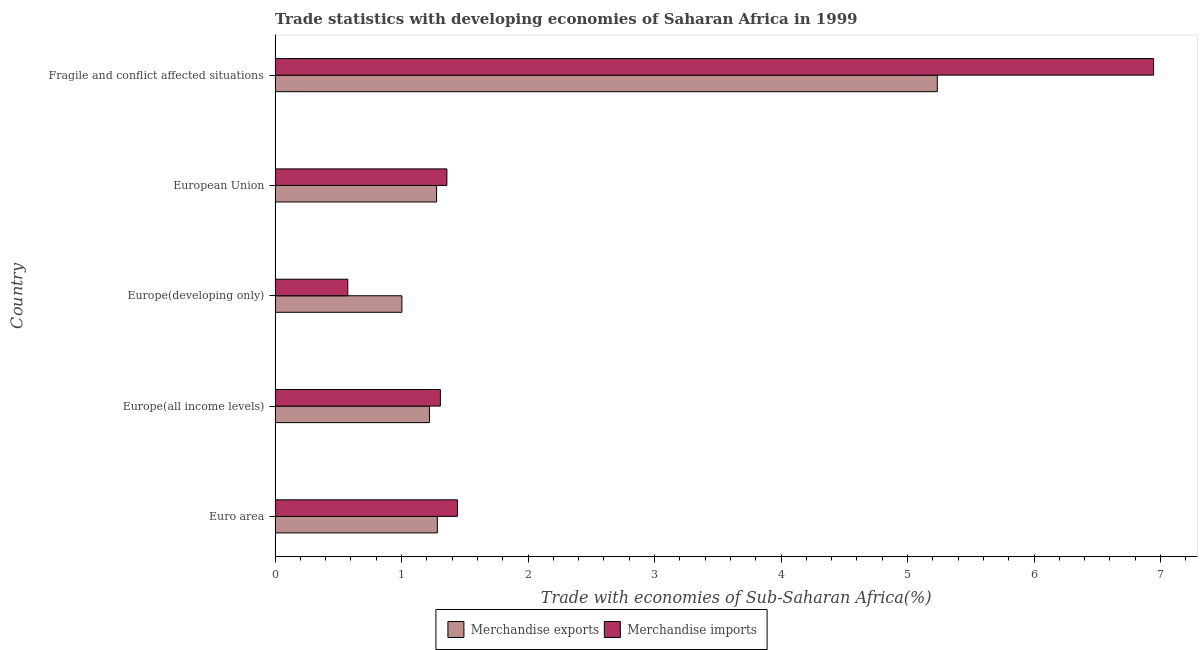Are the number of bars per tick equal to the number of legend labels?
Your answer should be very brief. Yes. How many bars are there on the 5th tick from the top?
Make the answer very short. 2. What is the label of the 3rd group of bars from the top?
Provide a short and direct response. Europe(developing only). In how many cases, is the number of bars for a given country not equal to the number of legend labels?
Keep it short and to the point. 0. What is the merchandise exports in Europe(all income levels)?
Your answer should be very brief. 1.22. Across all countries, what is the maximum merchandise imports?
Offer a terse response. 6.94. Across all countries, what is the minimum merchandise exports?
Offer a very short reply. 1. In which country was the merchandise imports maximum?
Give a very brief answer. Fragile and conflict affected situations. In which country was the merchandise exports minimum?
Your answer should be very brief. Europe(developing only). What is the total merchandise imports in the graph?
Offer a very short reply. 11.63. What is the difference between the merchandise imports in Europe(developing only) and that in European Union?
Ensure brevity in your answer.  -0.78. What is the difference between the merchandise imports in Europe(all income levels) and the merchandise exports in European Union?
Provide a succinct answer. 0.03. What is the average merchandise imports per country?
Provide a short and direct response. 2.33. What is the difference between the merchandise exports and merchandise imports in Europe(all income levels)?
Your response must be concise. -0.09. In how many countries, is the merchandise imports greater than 7 %?
Your answer should be compact. 0. What is the ratio of the merchandise imports in Euro area to that in Europe(all income levels)?
Your answer should be compact. 1.1. Is the merchandise exports in European Union less than that in Fragile and conflict affected situations?
Provide a succinct answer. Yes. What is the difference between the highest and the second highest merchandise exports?
Offer a very short reply. 3.95. What is the difference between the highest and the lowest merchandise imports?
Ensure brevity in your answer.  6.37. In how many countries, is the merchandise imports greater than the average merchandise imports taken over all countries?
Ensure brevity in your answer.  1. What does the 2nd bar from the top in Fragile and conflict affected situations represents?
Your response must be concise. Merchandise exports. What does the 1st bar from the bottom in European Union represents?
Offer a very short reply. Merchandise exports. How many countries are there in the graph?
Your answer should be compact. 5. What is the difference between two consecutive major ticks on the X-axis?
Ensure brevity in your answer.  1. Are the values on the major ticks of X-axis written in scientific E-notation?
Your answer should be very brief. No. Does the graph contain any zero values?
Keep it short and to the point. No. Does the graph contain grids?
Provide a succinct answer. No. How many legend labels are there?
Keep it short and to the point. 2. How are the legend labels stacked?
Offer a terse response. Horizontal. What is the title of the graph?
Give a very brief answer. Trade statistics with developing economies of Saharan Africa in 1999. Does "Domestic liabilities" appear as one of the legend labels in the graph?
Provide a short and direct response. No. What is the label or title of the X-axis?
Your response must be concise. Trade with economies of Sub-Saharan Africa(%). What is the Trade with economies of Sub-Saharan Africa(%) in Merchandise exports in Euro area?
Your response must be concise. 1.28. What is the Trade with economies of Sub-Saharan Africa(%) of Merchandise imports in Euro area?
Give a very brief answer. 1.44. What is the Trade with economies of Sub-Saharan Africa(%) of Merchandise exports in Europe(all income levels)?
Your answer should be very brief. 1.22. What is the Trade with economies of Sub-Saharan Africa(%) in Merchandise imports in Europe(all income levels)?
Your response must be concise. 1.31. What is the Trade with economies of Sub-Saharan Africa(%) of Merchandise exports in Europe(developing only)?
Offer a very short reply. 1. What is the Trade with economies of Sub-Saharan Africa(%) in Merchandise imports in Europe(developing only)?
Offer a very short reply. 0.57. What is the Trade with economies of Sub-Saharan Africa(%) in Merchandise exports in European Union?
Your response must be concise. 1.28. What is the Trade with economies of Sub-Saharan Africa(%) of Merchandise imports in European Union?
Your answer should be very brief. 1.36. What is the Trade with economies of Sub-Saharan Africa(%) of Merchandise exports in Fragile and conflict affected situations?
Provide a succinct answer. 5.24. What is the Trade with economies of Sub-Saharan Africa(%) in Merchandise imports in Fragile and conflict affected situations?
Your response must be concise. 6.94. Across all countries, what is the maximum Trade with economies of Sub-Saharan Africa(%) in Merchandise exports?
Keep it short and to the point. 5.24. Across all countries, what is the maximum Trade with economies of Sub-Saharan Africa(%) of Merchandise imports?
Make the answer very short. 6.94. Across all countries, what is the minimum Trade with economies of Sub-Saharan Africa(%) of Merchandise exports?
Your response must be concise. 1. Across all countries, what is the minimum Trade with economies of Sub-Saharan Africa(%) of Merchandise imports?
Give a very brief answer. 0.57. What is the total Trade with economies of Sub-Saharan Africa(%) in Merchandise exports in the graph?
Give a very brief answer. 10.02. What is the total Trade with economies of Sub-Saharan Africa(%) in Merchandise imports in the graph?
Offer a terse response. 11.63. What is the difference between the Trade with economies of Sub-Saharan Africa(%) in Merchandise exports in Euro area and that in Europe(all income levels)?
Ensure brevity in your answer.  0.06. What is the difference between the Trade with economies of Sub-Saharan Africa(%) in Merchandise imports in Euro area and that in Europe(all income levels)?
Make the answer very short. 0.14. What is the difference between the Trade with economies of Sub-Saharan Africa(%) of Merchandise exports in Euro area and that in Europe(developing only)?
Your response must be concise. 0.28. What is the difference between the Trade with economies of Sub-Saharan Africa(%) of Merchandise imports in Euro area and that in Europe(developing only)?
Your answer should be very brief. 0.87. What is the difference between the Trade with economies of Sub-Saharan Africa(%) in Merchandise exports in Euro area and that in European Union?
Offer a very short reply. 0.01. What is the difference between the Trade with economies of Sub-Saharan Africa(%) in Merchandise imports in Euro area and that in European Union?
Offer a terse response. 0.08. What is the difference between the Trade with economies of Sub-Saharan Africa(%) of Merchandise exports in Euro area and that in Fragile and conflict affected situations?
Provide a short and direct response. -3.95. What is the difference between the Trade with economies of Sub-Saharan Africa(%) of Merchandise imports in Euro area and that in Fragile and conflict affected situations?
Provide a succinct answer. -5.5. What is the difference between the Trade with economies of Sub-Saharan Africa(%) in Merchandise exports in Europe(all income levels) and that in Europe(developing only)?
Make the answer very short. 0.22. What is the difference between the Trade with economies of Sub-Saharan Africa(%) of Merchandise imports in Europe(all income levels) and that in Europe(developing only)?
Ensure brevity in your answer.  0.73. What is the difference between the Trade with economies of Sub-Saharan Africa(%) in Merchandise exports in Europe(all income levels) and that in European Union?
Provide a succinct answer. -0.06. What is the difference between the Trade with economies of Sub-Saharan Africa(%) of Merchandise imports in Europe(all income levels) and that in European Union?
Make the answer very short. -0.05. What is the difference between the Trade with economies of Sub-Saharan Africa(%) of Merchandise exports in Europe(all income levels) and that in Fragile and conflict affected situations?
Ensure brevity in your answer.  -4.01. What is the difference between the Trade with economies of Sub-Saharan Africa(%) of Merchandise imports in Europe(all income levels) and that in Fragile and conflict affected situations?
Make the answer very short. -5.64. What is the difference between the Trade with economies of Sub-Saharan Africa(%) of Merchandise exports in Europe(developing only) and that in European Union?
Provide a short and direct response. -0.27. What is the difference between the Trade with economies of Sub-Saharan Africa(%) in Merchandise imports in Europe(developing only) and that in European Union?
Offer a very short reply. -0.78. What is the difference between the Trade with economies of Sub-Saharan Africa(%) in Merchandise exports in Europe(developing only) and that in Fragile and conflict affected situations?
Your answer should be compact. -4.23. What is the difference between the Trade with economies of Sub-Saharan Africa(%) of Merchandise imports in Europe(developing only) and that in Fragile and conflict affected situations?
Your answer should be compact. -6.37. What is the difference between the Trade with economies of Sub-Saharan Africa(%) of Merchandise exports in European Union and that in Fragile and conflict affected situations?
Your answer should be compact. -3.96. What is the difference between the Trade with economies of Sub-Saharan Africa(%) in Merchandise imports in European Union and that in Fragile and conflict affected situations?
Your response must be concise. -5.59. What is the difference between the Trade with economies of Sub-Saharan Africa(%) in Merchandise exports in Euro area and the Trade with economies of Sub-Saharan Africa(%) in Merchandise imports in Europe(all income levels)?
Your answer should be compact. -0.02. What is the difference between the Trade with economies of Sub-Saharan Africa(%) of Merchandise exports in Euro area and the Trade with economies of Sub-Saharan Africa(%) of Merchandise imports in Europe(developing only)?
Offer a terse response. 0.71. What is the difference between the Trade with economies of Sub-Saharan Africa(%) in Merchandise exports in Euro area and the Trade with economies of Sub-Saharan Africa(%) in Merchandise imports in European Union?
Ensure brevity in your answer.  -0.08. What is the difference between the Trade with economies of Sub-Saharan Africa(%) of Merchandise exports in Euro area and the Trade with economies of Sub-Saharan Africa(%) of Merchandise imports in Fragile and conflict affected situations?
Keep it short and to the point. -5.66. What is the difference between the Trade with economies of Sub-Saharan Africa(%) of Merchandise exports in Europe(all income levels) and the Trade with economies of Sub-Saharan Africa(%) of Merchandise imports in Europe(developing only)?
Keep it short and to the point. 0.65. What is the difference between the Trade with economies of Sub-Saharan Africa(%) in Merchandise exports in Europe(all income levels) and the Trade with economies of Sub-Saharan Africa(%) in Merchandise imports in European Union?
Provide a short and direct response. -0.14. What is the difference between the Trade with economies of Sub-Saharan Africa(%) in Merchandise exports in Europe(all income levels) and the Trade with economies of Sub-Saharan Africa(%) in Merchandise imports in Fragile and conflict affected situations?
Offer a terse response. -5.72. What is the difference between the Trade with economies of Sub-Saharan Africa(%) in Merchandise exports in Europe(developing only) and the Trade with economies of Sub-Saharan Africa(%) in Merchandise imports in European Union?
Provide a short and direct response. -0.36. What is the difference between the Trade with economies of Sub-Saharan Africa(%) in Merchandise exports in Europe(developing only) and the Trade with economies of Sub-Saharan Africa(%) in Merchandise imports in Fragile and conflict affected situations?
Give a very brief answer. -5.94. What is the difference between the Trade with economies of Sub-Saharan Africa(%) of Merchandise exports in European Union and the Trade with economies of Sub-Saharan Africa(%) of Merchandise imports in Fragile and conflict affected situations?
Offer a terse response. -5.67. What is the average Trade with economies of Sub-Saharan Africa(%) of Merchandise exports per country?
Keep it short and to the point. 2. What is the average Trade with economies of Sub-Saharan Africa(%) in Merchandise imports per country?
Your response must be concise. 2.33. What is the difference between the Trade with economies of Sub-Saharan Africa(%) of Merchandise exports and Trade with economies of Sub-Saharan Africa(%) of Merchandise imports in Euro area?
Make the answer very short. -0.16. What is the difference between the Trade with economies of Sub-Saharan Africa(%) of Merchandise exports and Trade with economies of Sub-Saharan Africa(%) of Merchandise imports in Europe(all income levels)?
Offer a very short reply. -0.09. What is the difference between the Trade with economies of Sub-Saharan Africa(%) of Merchandise exports and Trade with economies of Sub-Saharan Africa(%) of Merchandise imports in Europe(developing only)?
Offer a very short reply. 0.43. What is the difference between the Trade with economies of Sub-Saharan Africa(%) in Merchandise exports and Trade with economies of Sub-Saharan Africa(%) in Merchandise imports in European Union?
Offer a very short reply. -0.08. What is the difference between the Trade with economies of Sub-Saharan Africa(%) of Merchandise exports and Trade with economies of Sub-Saharan Africa(%) of Merchandise imports in Fragile and conflict affected situations?
Ensure brevity in your answer.  -1.71. What is the ratio of the Trade with economies of Sub-Saharan Africa(%) in Merchandise exports in Euro area to that in Europe(all income levels)?
Offer a very short reply. 1.05. What is the ratio of the Trade with economies of Sub-Saharan Africa(%) in Merchandise imports in Euro area to that in Europe(all income levels)?
Ensure brevity in your answer.  1.1. What is the ratio of the Trade with economies of Sub-Saharan Africa(%) in Merchandise exports in Euro area to that in Europe(developing only)?
Ensure brevity in your answer.  1.28. What is the ratio of the Trade with economies of Sub-Saharan Africa(%) in Merchandise imports in Euro area to that in Europe(developing only)?
Offer a very short reply. 2.51. What is the ratio of the Trade with economies of Sub-Saharan Africa(%) in Merchandise exports in Euro area to that in European Union?
Give a very brief answer. 1. What is the ratio of the Trade with economies of Sub-Saharan Africa(%) of Merchandise imports in Euro area to that in European Union?
Offer a very short reply. 1.06. What is the ratio of the Trade with economies of Sub-Saharan Africa(%) of Merchandise exports in Euro area to that in Fragile and conflict affected situations?
Your response must be concise. 0.24. What is the ratio of the Trade with economies of Sub-Saharan Africa(%) of Merchandise imports in Euro area to that in Fragile and conflict affected situations?
Give a very brief answer. 0.21. What is the ratio of the Trade with economies of Sub-Saharan Africa(%) in Merchandise exports in Europe(all income levels) to that in Europe(developing only)?
Give a very brief answer. 1.22. What is the ratio of the Trade with economies of Sub-Saharan Africa(%) of Merchandise imports in Europe(all income levels) to that in Europe(developing only)?
Your answer should be compact. 2.27. What is the ratio of the Trade with economies of Sub-Saharan Africa(%) of Merchandise exports in Europe(all income levels) to that in European Union?
Your response must be concise. 0.96. What is the ratio of the Trade with economies of Sub-Saharan Africa(%) of Merchandise imports in Europe(all income levels) to that in European Union?
Offer a terse response. 0.96. What is the ratio of the Trade with economies of Sub-Saharan Africa(%) in Merchandise exports in Europe(all income levels) to that in Fragile and conflict affected situations?
Give a very brief answer. 0.23. What is the ratio of the Trade with economies of Sub-Saharan Africa(%) of Merchandise imports in Europe(all income levels) to that in Fragile and conflict affected situations?
Provide a succinct answer. 0.19. What is the ratio of the Trade with economies of Sub-Saharan Africa(%) of Merchandise exports in Europe(developing only) to that in European Union?
Give a very brief answer. 0.79. What is the ratio of the Trade with economies of Sub-Saharan Africa(%) of Merchandise imports in Europe(developing only) to that in European Union?
Provide a short and direct response. 0.42. What is the ratio of the Trade with economies of Sub-Saharan Africa(%) in Merchandise exports in Europe(developing only) to that in Fragile and conflict affected situations?
Give a very brief answer. 0.19. What is the ratio of the Trade with economies of Sub-Saharan Africa(%) in Merchandise imports in Europe(developing only) to that in Fragile and conflict affected situations?
Offer a terse response. 0.08. What is the ratio of the Trade with economies of Sub-Saharan Africa(%) of Merchandise exports in European Union to that in Fragile and conflict affected situations?
Your answer should be compact. 0.24. What is the ratio of the Trade with economies of Sub-Saharan Africa(%) in Merchandise imports in European Union to that in Fragile and conflict affected situations?
Give a very brief answer. 0.2. What is the difference between the highest and the second highest Trade with economies of Sub-Saharan Africa(%) of Merchandise exports?
Make the answer very short. 3.95. What is the difference between the highest and the second highest Trade with economies of Sub-Saharan Africa(%) of Merchandise imports?
Keep it short and to the point. 5.5. What is the difference between the highest and the lowest Trade with economies of Sub-Saharan Africa(%) of Merchandise exports?
Your response must be concise. 4.23. What is the difference between the highest and the lowest Trade with economies of Sub-Saharan Africa(%) of Merchandise imports?
Provide a short and direct response. 6.37. 